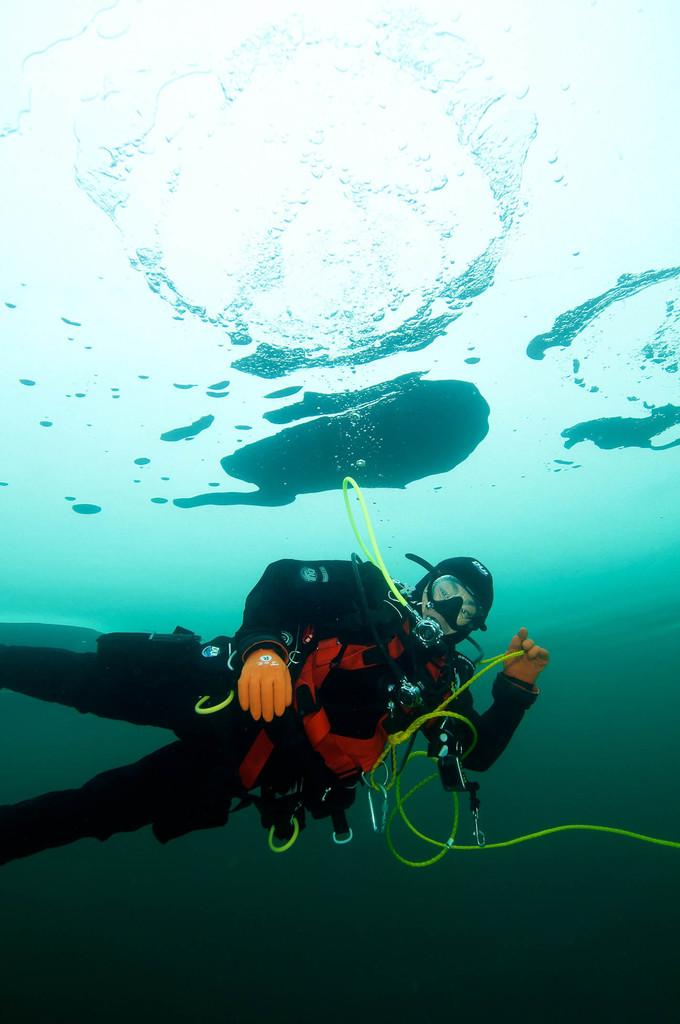What activity is the person in the image engaged in? The person is doing scuba diving. Where is the scuba diving taking place? The scuba diving is taking place in the water. What color is the cemetery visible in the image? There is no cemetery present in the image; it features a person doing scuba diving in the water. 